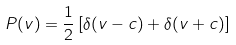<formula> <loc_0><loc_0><loc_500><loc_500>P ( v ) = \frac { 1 } { 2 } \left [ \delta ( v - c ) + \delta ( v + c ) \right ]</formula> 